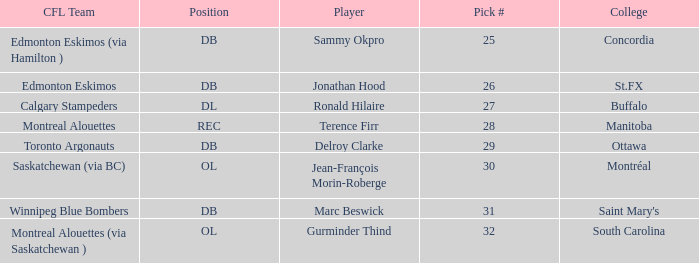Which Pick # has a College of concordia? 25.0. 